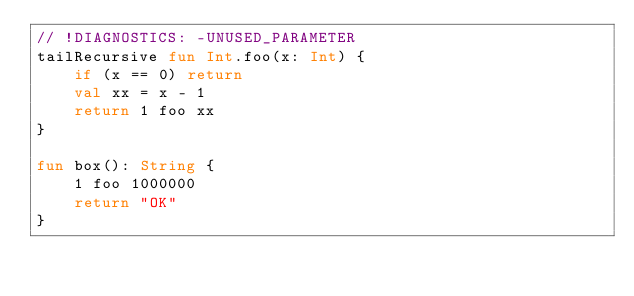Convert code to text. <code><loc_0><loc_0><loc_500><loc_500><_Kotlin_>// !DIAGNOSTICS: -UNUSED_PARAMETER
tailRecursive fun Int.foo(x: Int) {
    if (x == 0) return
    val xx = x - 1
    return 1 foo xx
}

fun box(): String {
    1 foo 1000000
    return "OK"
}</code> 